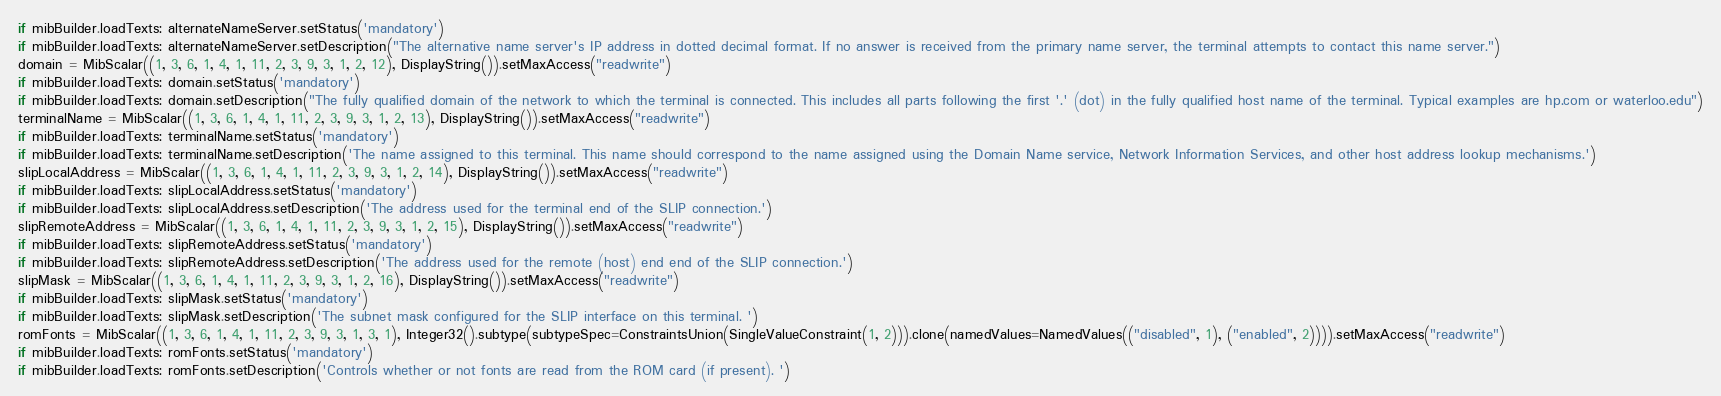Convert code to text. <code><loc_0><loc_0><loc_500><loc_500><_Python_>if mibBuilder.loadTexts: alternateNameServer.setStatus('mandatory')
if mibBuilder.loadTexts: alternateNameServer.setDescription("The alternative name server's IP address in dotted decimal format. If no answer is received from the primary name server, the terminal attempts to contact this name server.")
domain = MibScalar((1, 3, 6, 1, 4, 1, 11, 2, 3, 9, 3, 1, 2, 12), DisplayString()).setMaxAccess("readwrite")
if mibBuilder.loadTexts: domain.setStatus('mandatory')
if mibBuilder.loadTexts: domain.setDescription("The fully qualified domain of the network to which the terminal is connected. This includes all parts following the first '.' (dot) in the fully qualified host name of the terminal. Typical examples are hp.com or waterloo.edu")
terminalName = MibScalar((1, 3, 6, 1, 4, 1, 11, 2, 3, 9, 3, 1, 2, 13), DisplayString()).setMaxAccess("readwrite")
if mibBuilder.loadTexts: terminalName.setStatus('mandatory')
if mibBuilder.loadTexts: terminalName.setDescription('The name assigned to this terminal. This name should correspond to the name assigned using the Domain Name service, Network Information Services, and other host address lookup mechanisms.')
slipLocalAddress = MibScalar((1, 3, 6, 1, 4, 1, 11, 2, 3, 9, 3, 1, 2, 14), DisplayString()).setMaxAccess("readwrite")
if mibBuilder.loadTexts: slipLocalAddress.setStatus('mandatory')
if mibBuilder.loadTexts: slipLocalAddress.setDescription('The address used for the terminal end of the SLIP connection.')
slipRemoteAddress = MibScalar((1, 3, 6, 1, 4, 1, 11, 2, 3, 9, 3, 1, 2, 15), DisplayString()).setMaxAccess("readwrite")
if mibBuilder.loadTexts: slipRemoteAddress.setStatus('mandatory')
if mibBuilder.loadTexts: slipRemoteAddress.setDescription('The address used for the remote (host) end end of the SLIP connection.')
slipMask = MibScalar((1, 3, 6, 1, 4, 1, 11, 2, 3, 9, 3, 1, 2, 16), DisplayString()).setMaxAccess("readwrite")
if mibBuilder.loadTexts: slipMask.setStatus('mandatory')
if mibBuilder.loadTexts: slipMask.setDescription('The subnet mask configured for the SLIP interface on this terminal. ')
romFonts = MibScalar((1, 3, 6, 1, 4, 1, 11, 2, 3, 9, 3, 1, 3, 1), Integer32().subtype(subtypeSpec=ConstraintsUnion(SingleValueConstraint(1, 2))).clone(namedValues=NamedValues(("disabled", 1), ("enabled", 2)))).setMaxAccess("readwrite")
if mibBuilder.loadTexts: romFonts.setStatus('mandatory')
if mibBuilder.loadTexts: romFonts.setDescription('Controls whether or not fonts are read from the ROM card (if present). ')</code> 